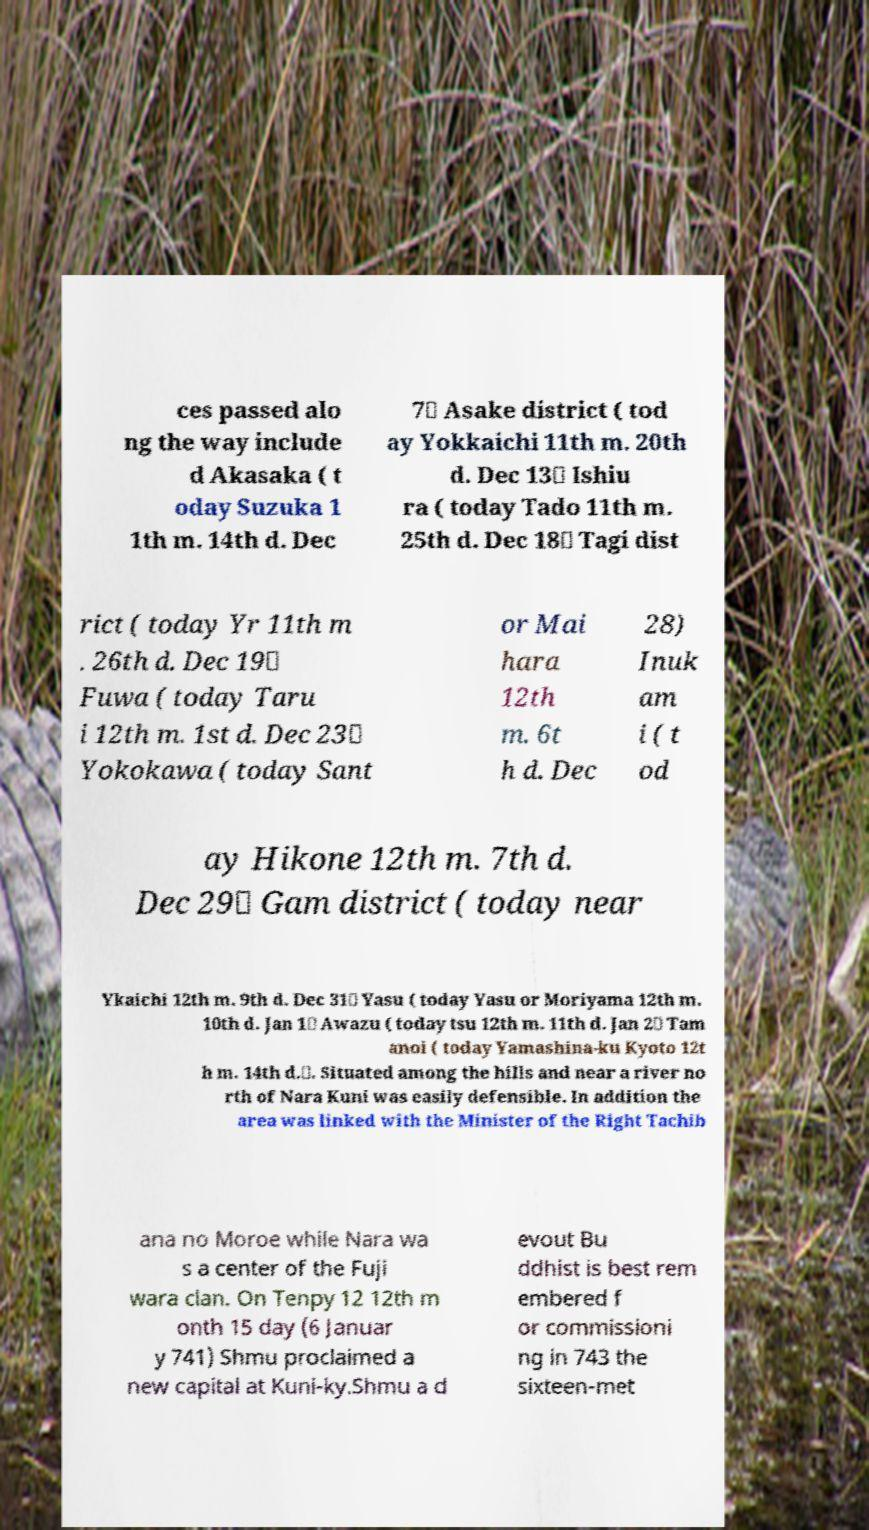I need the written content from this picture converted into text. Can you do that? ces passed alo ng the way include d Akasaka ( t oday Suzuka 1 1th m. 14th d. Dec 7） Asake district ( tod ay Yokkaichi 11th m. 20th d. Dec 13） Ishiu ra ( today Tado 11th m. 25th d. Dec 18） Tagi dist rict ( today Yr 11th m . 26th d. Dec 19） Fuwa ( today Taru i 12th m. 1st d. Dec 23） Yokokawa ( today Sant or Mai hara 12th m. 6t h d. Dec 28) Inuk am i ( t od ay Hikone 12th m. 7th d. Dec 29） Gam district ( today near Ykaichi 12th m. 9th d. Dec 31） Yasu ( today Yasu or Moriyama 12th m. 10th d. Jan 1） Awazu ( today tsu 12th m. 11th d. Jan 2） Tam anoi ( today Yamashina-ku Kyoto 12t h m. 14th d.）. Situated among the hills and near a river no rth of Nara Kuni was easily defensible. In addition the area was linked with the Minister of the Right Tachib ana no Moroe while Nara wa s a center of the Fuji wara clan. On Tenpy 12 12th m onth 15 day (6 Januar y 741) Shmu proclaimed a new capital at Kuni-ky.Shmu a d evout Bu ddhist is best rem embered f or commissioni ng in 743 the sixteen-met 